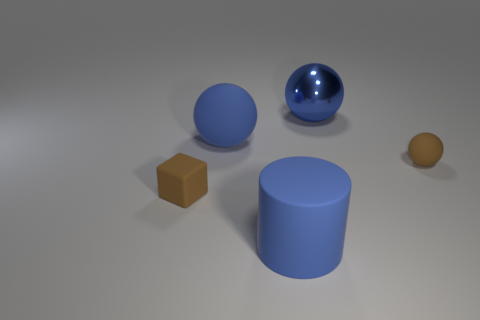Is the color of the small rubber ball the same as the big matte sphere?
Keep it short and to the point. No. What number of metallic things are small brown objects or brown balls?
Keep it short and to the point. 0. How many blue spheres are there?
Your answer should be compact. 2. Are the brown object that is to the left of the tiny brown sphere and the blue object in front of the tiny brown cube made of the same material?
Offer a terse response. Yes. There is a large rubber thing that is the same shape as the big blue metal thing; what is its color?
Give a very brief answer. Blue. There is a tiny brown thing right of the brown thing that is on the left side of the blue matte cylinder; what is its material?
Offer a terse response. Rubber. Does the blue thing in front of the tiny rubber sphere have the same shape as the tiny brown thing that is left of the tiny rubber ball?
Offer a terse response. No. How big is the matte thing that is both left of the big blue rubber cylinder and to the right of the small brown rubber cube?
Your response must be concise. Large. How many other objects are there of the same color as the rubber cylinder?
Provide a short and direct response. 2. Are there an equal number of tiny cubes and tiny matte objects?
Your answer should be compact. No. 